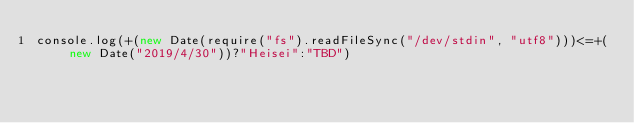<code> <loc_0><loc_0><loc_500><loc_500><_JavaScript_>console.log(+(new Date(require("fs").readFileSync("/dev/stdin", "utf8")))<=+(new Date("2019/4/30"))?"Heisei":"TBD")</code> 